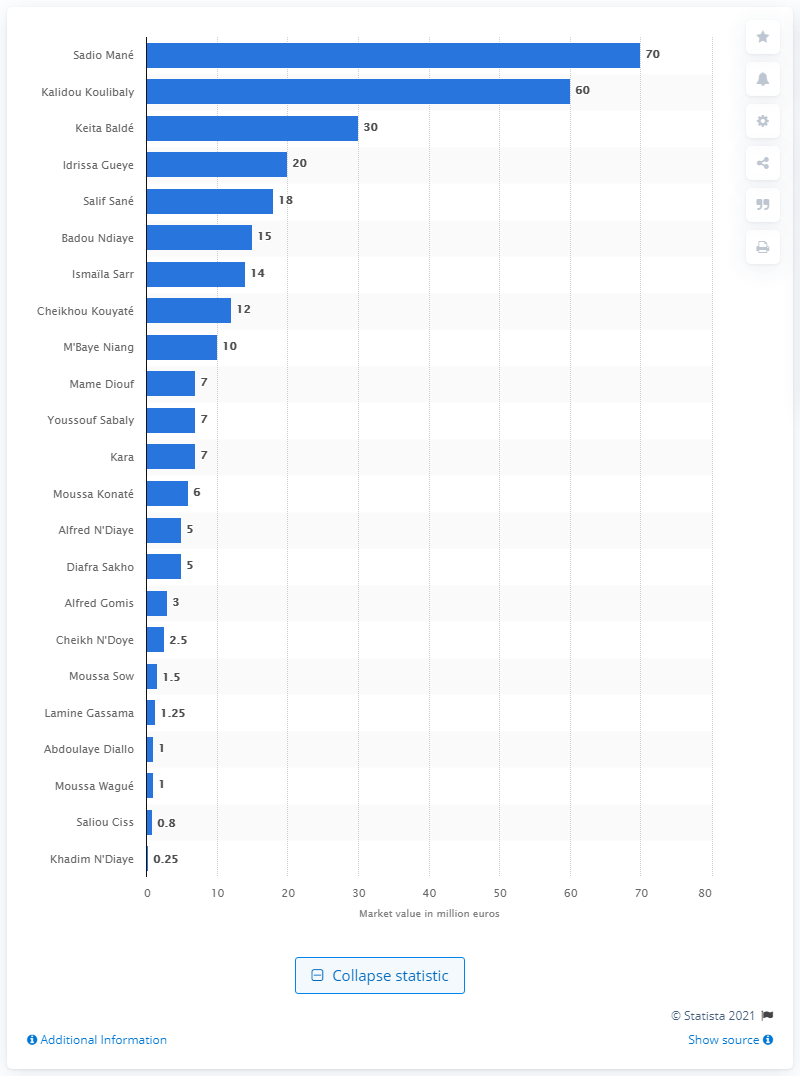Indicate a few pertinent items in this graphic. The market value of Sadio Man was 70 million dollars. 